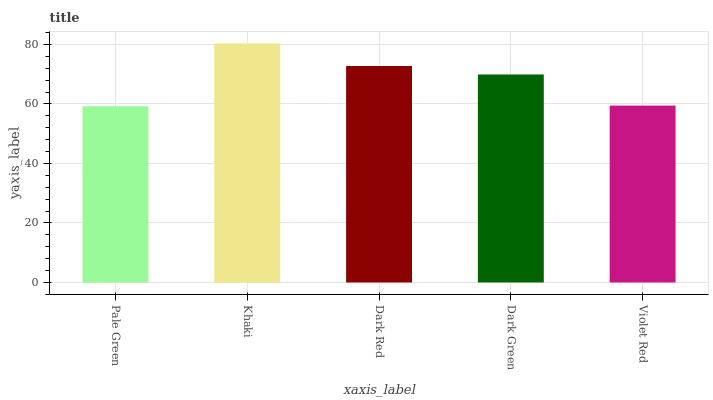Is Pale Green the minimum?
Answer yes or no. Yes. Is Khaki the maximum?
Answer yes or no. Yes. Is Dark Red the minimum?
Answer yes or no. No. Is Dark Red the maximum?
Answer yes or no. No. Is Khaki greater than Dark Red?
Answer yes or no. Yes. Is Dark Red less than Khaki?
Answer yes or no. Yes. Is Dark Red greater than Khaki?
Answer yes or no. No. Is Khaki less than Dark Red?
Answer yes or no. No. Is Dark Green the high median?
Answer yes or no. Yes. Is Dark Green the low median?
Answer yes or no. Yes. Is Pale Green the high median?
Answer yes or no. No. Is Khaki the low median?
Answer yes or no. No. 